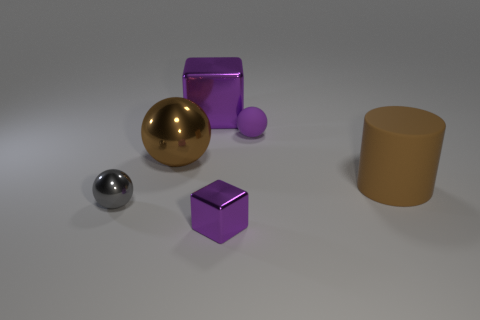Add 4 big cyan metal balls. How many objects exist? 10 Subtract all cubes. How many objects are left? 4 Add 5 purple metallic things. How many purple metallic things are left? 7 Add 2 large metal objects. How many large metal objects exist? 4 Subtract 0 red cubes. How many objects are left? 6 Subtract all large gray cylinders. Subtract all big matte cylinders. How many objects are left? 5 